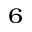<formula> <loc_0><loc_0><loc_500><loc_500>^ { 6 }</formula> 